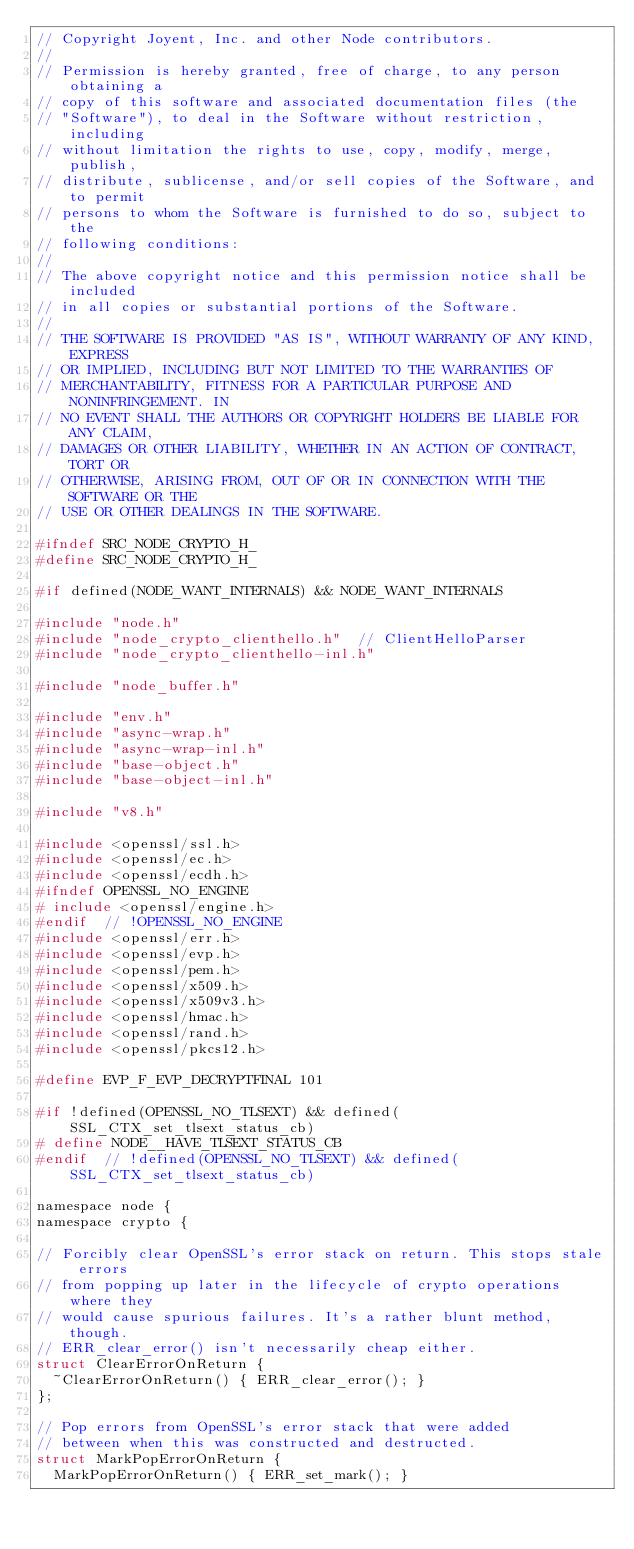<code> <loc_0><loc_0><loc_500><loc_500><_C_>// Copyright Joyent, Inc. and other Node contributors.
//
// Permission is hereby granted, free of charge, to any person obtaining a
// copy of this software and associated documentation files (the
// "Software"), to deal in the Software without restriction, including
// without limitation the rights to use, copy, modify, merge, publish,
// distribute, sublicense, and/or sell copies of the Software, and to permit
// persons to whom the Software is furnished to do so, subject to the
// following conditions:
//
// The above copyright notice and this permission notice shall be included
// in all copies or substantial portions of the Software.
//
// THE SOFTWARE IS PROVIDED "AS IS", WITHOUT WARRANTY OF ANY KIND, EXPRESS
// OR IMPLIED, INCLUDING BUT NOT LIMITED TO THE WARRANTIES OF
// MERCHANTABILITY, FITNESS FOR A PARTICULAR PURPOSE AND NONINFRINGEMENT. IN
// NO EVENT SHALL THE AUTHORS OR COPYRIGHT HOLDERS BE LIABLE FOR ANY CLAIM,
// DAMAGES OR OTHER LIABILITY, WHETHER IN AN ACTION OF CONTRACT, TORT OR
// OTHERWISE, ARISING FROM, OUT OF OR IN CONNECTION WITH THE SOFTWARE OR THE
// USE OR OTHER DEALINGS IN THE SOFTWARE.

#ifndef SRC_NODE_CRYPTO_H_
#define SRC_NODE_CRYPTO_H_

#if defined(NODE_WANT_INTERNALS) && NODE_WANT_INTERNALS

#include "node.h"
#include "node_crypto_clienthello.h"  // ClientHelloParser
#include "node_crypto_clienthello-inl.h"

#include "node_buffer.h"

#include "env.h"
#include "async-wrap.h"
#include "async-wrap-inl.h"
#include "base-object.h"
#include "base-object-inl.h"

#include "v8.h"

#include <openssl/ssl.h>
#include <openssl/ec.h>
#include <openssl/ecdh.h>
#ifndef OPENSSL_NO_ENGINE
# include <openssl/engine.h>
#endif  // !OPENSSL_NO_ENGINE
#include <openssl/err.h>
#include <openssl/evp.h>
#include <openssl/pem.h>
#include <openssl/x509.h>
#include <openssl/x509v3.h>
#include <openssl/hmac.h>
#include <openssl/rand.h>
#include <openssl/pkcs12.h>

#define EVP_F_EVP_DECRYPTFINAL 101

#if !defined(OPENSSL_NO_TLSEXT) && defined(SSL_CTX_set_tlsext_status_cb)
# define NODE__HAVE_TLSEXT_STATUS_CB
#endif  // !defined(OPENSSL_NO_TLSEXT) && defined(SSL_CTX_set_tlsext_status_cb)

namespace node {
namespace crypto {

// Forcibly clear OpenSSL's error stack on return. This stops stale errors
// from popping up later in the lifecycle of crypto operations where they
// would cause spurious failures. It's a rather blunt method, though.
// ERR_clear_error() isn't necessarily cheap either.
struct ClearErrorOnReturn {
  ~ClearErrorOnReturn() { ERR_clear_error(); }
};

// Pop errors from OpenSSL's error stack that were added
// between when this was constructed and destructed.
struct MarkPopErrorOnReturn {
  MarkPopErrorOnReturn() { ERR_set_mark(); }</code> 